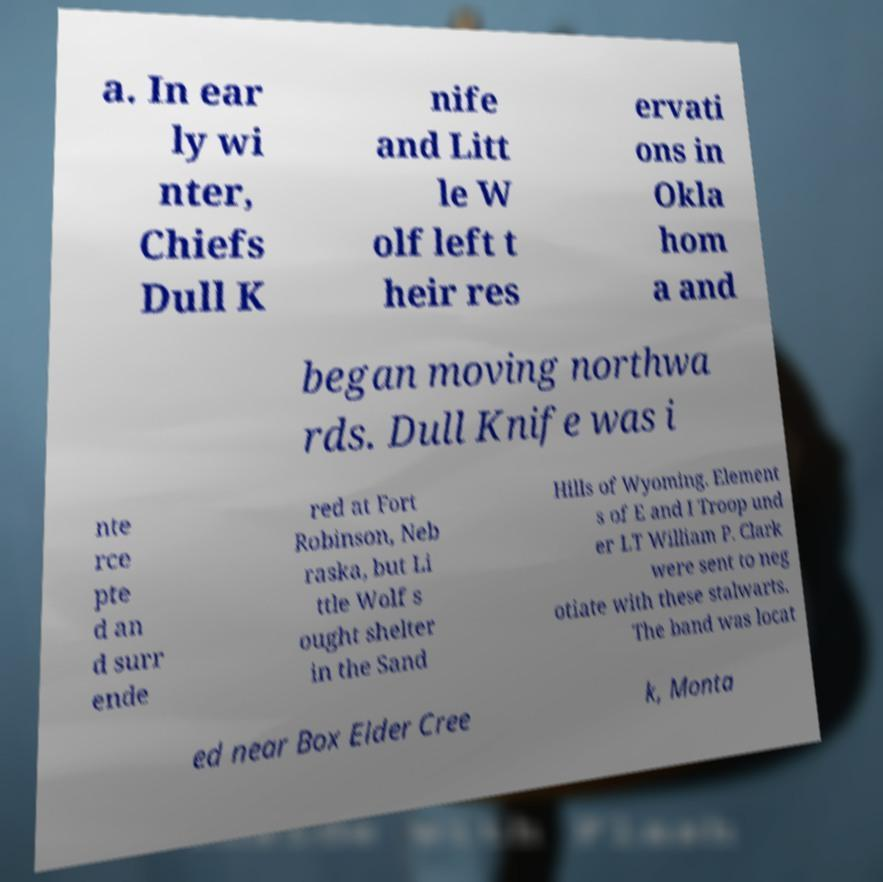Could you assist in decoding the text presented in this image and type it out clearly? a. In ear ly wi nter, Chiefs Dull K nife and Litt le W olf left t heir res ervati ons in Okla hom a and began moving northwa rds. Dull Knife was i nte rce pte d an d surr ende red at Fort Robinson, Neb raska, but Li ttle Wolf s ought shelter in the Sand Hills of Wyoming. Element s of E and I Troop und er LT William P. Clark were sent to neg otiate with these stalwarts. The band was locat ed near Box Elder Cree k, Monta 